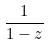<formula> <loc_0><loc_0><loc_500><loc_500>\frac { 1 } { 1 - z }</formula> 